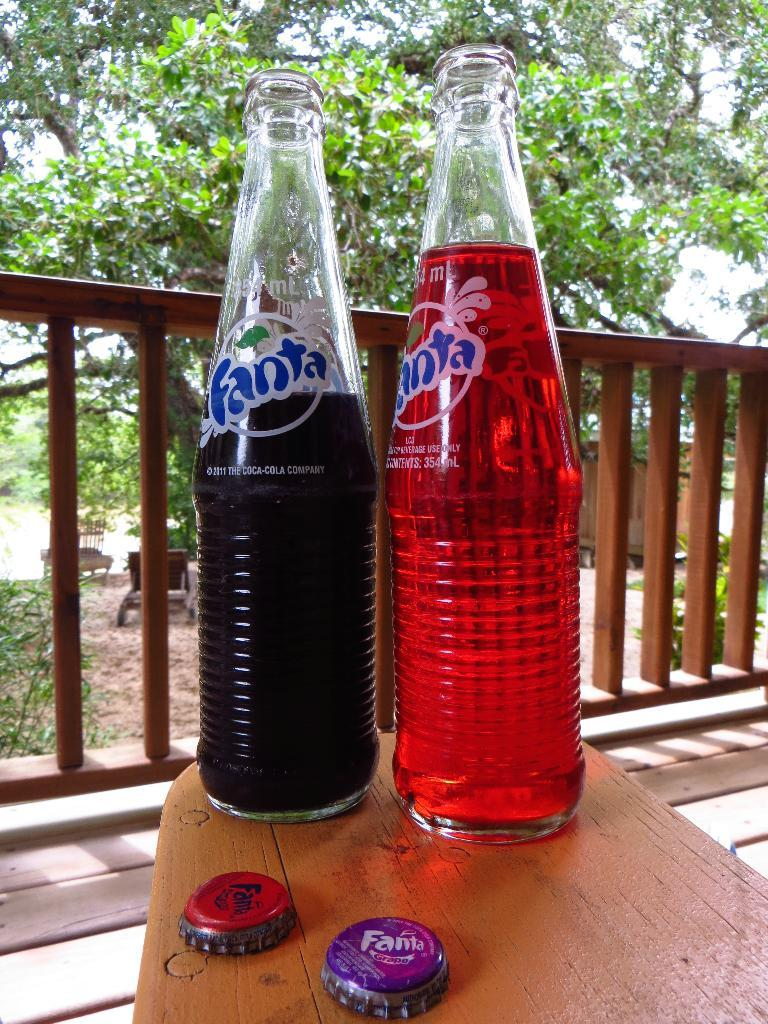<image>
Share a concise interpretation of the image provided. Two bottles of Fanta soda pop on top of a table. 